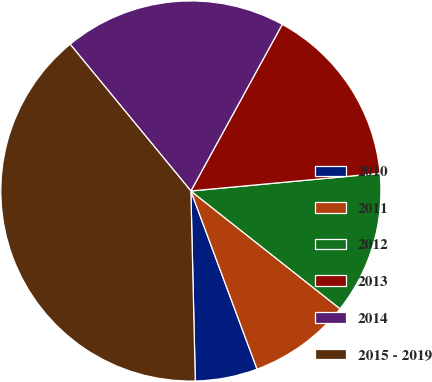<chart> <loc_0><loc_0><loc_500><loc_500><pie_chart><fcel>2010<fcel>2011<fcel>2012<fcel>2013<fcel>2014<fcel>2015 - 2019<nl><fcel>5.29%<fcel>8.7%<fcel>12.12%<fcel>15.53%<fcel>18.94%<fcel>39.41%<nl></chart> 